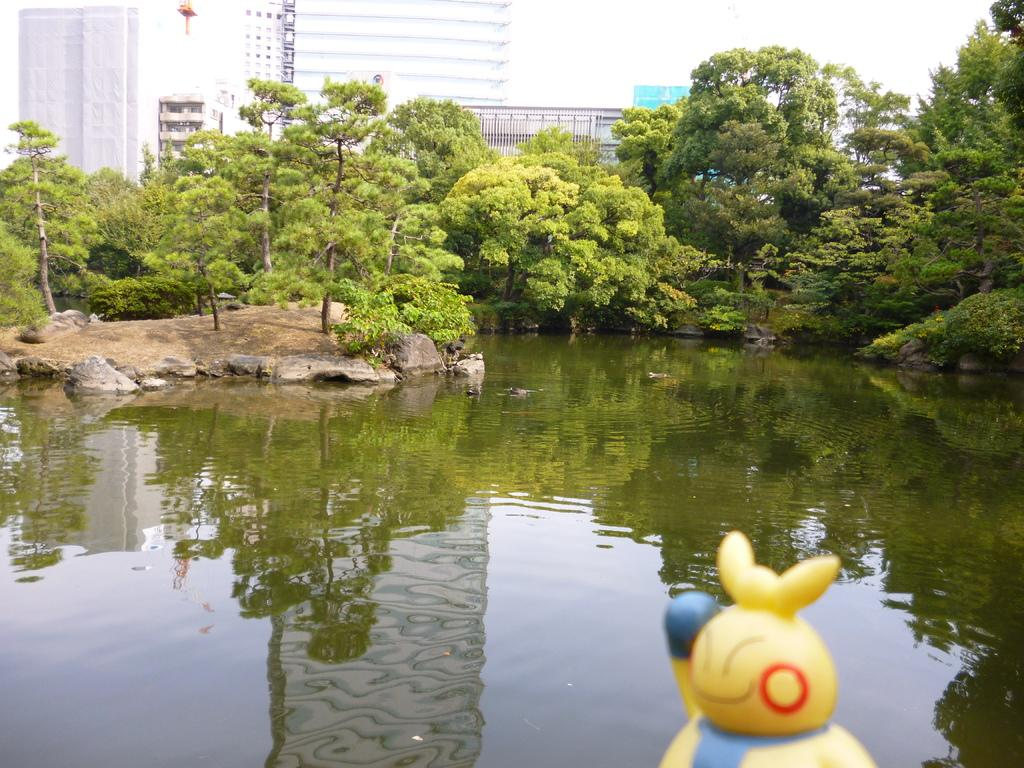What is located in the front of the image? There is a doll in the front of the image. What is in the center of the image? There is water in the center of the image. What can be seen in the background of the image? There are trees and buildings in the background of the image. What does the dad say about the branch in the image? There is no dad or branch present in the image. What season is it in the image? The provided facts do not mention the season, so it cannot be determined from the image. 